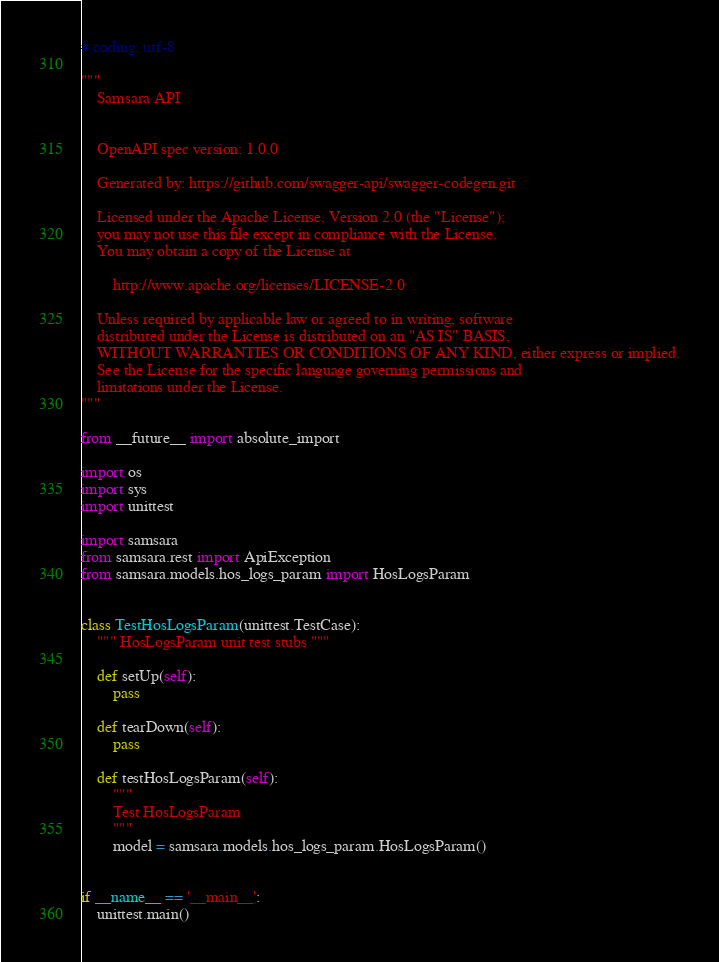<code> <loc_0><loc_0><loc_500><loc_500><_Python_># coding: utf-8

"""
    Samsara API


    OpenAPI spec version: 1.0.0
    
    Generated by: https://github.com/swagger-api/swagger-codegen.git

    Licensed under the Apache License, Version 2.0 (the "License");
    you may not use this file except in compliance with the License.
    You may obtain a copy of the License at

        http://www.apache.org/licenses/LICENSE-2.0

    Unless required by applicable law or agreed to in writing, software
    distributed under the License is distributed on an "AS IS" BASIS,
    WITHOUT WARRANTIES OR CONDITIONS OF ANY KIND, either express or implied.
    See the License for the specific language governing permissions and
    limitations under the License.
"""

from __future__ import absolute_import

import os
import sys
import unittest

import samsara
from samsara.rest import ApiException
from samsara.models.hos_logs_param import HosLogsParam


class TestHosLogsParam(unittest.TestCase):
    """ HosLogsParam unit test stubs """

    def setUp(self):
        pass

    def tearDown(self):
        pass

    def testHosLogsParam(self):
        """
        Test HosLogsParam
        """
        model = samsara.models.hos_logs_param.HosLogsParam()


if __name__ == '__main__':
    unittest.main()
</code> 